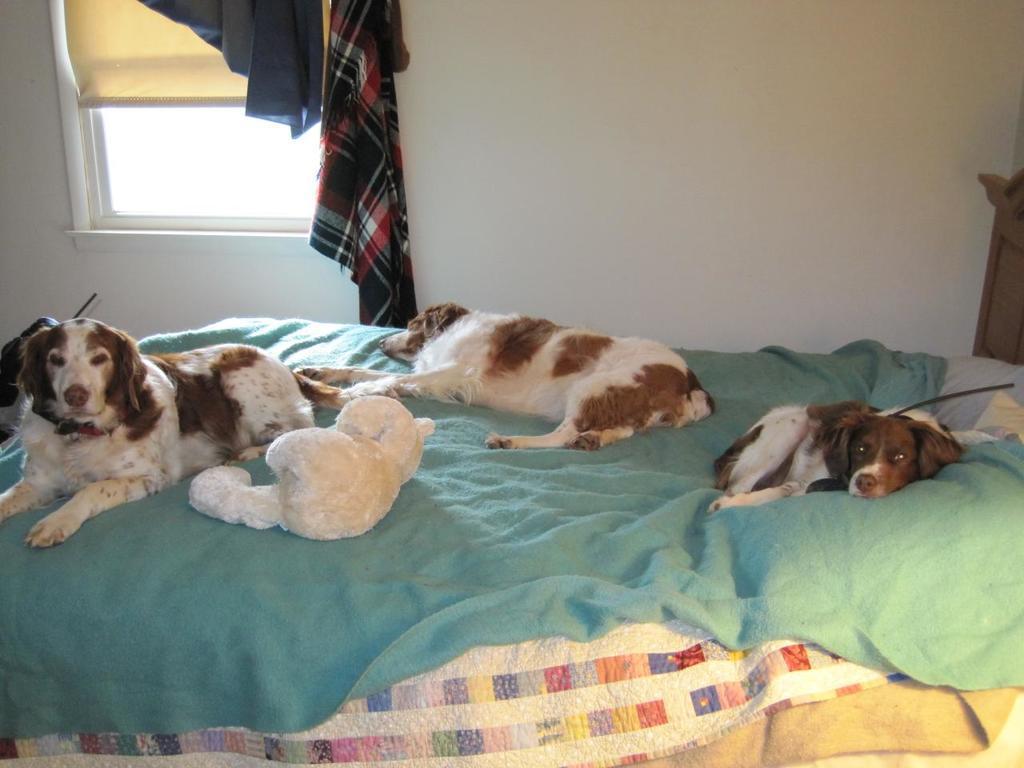Describe this image in one or two sentences. In this image I can see a three dogs lying on the bed. At the back side there is a wall and a window. 